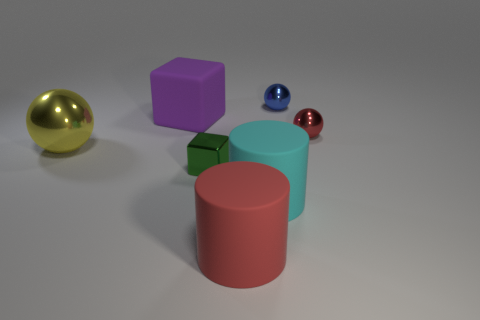Add 2 blue shiny objects. How many objects exist? 9 Subtract all cylinders. How many objects are left? 5 Subtract 0 yellow cylinders. How many objects are left? 7 Subtract all large yellow shiny objects. Subtract all red spheres. How many objects are left? 5 Add 1 big red things. How many big red things are left? 2 Add 2 tiny metal spheres. How many tiny metal spheres exist? 4 